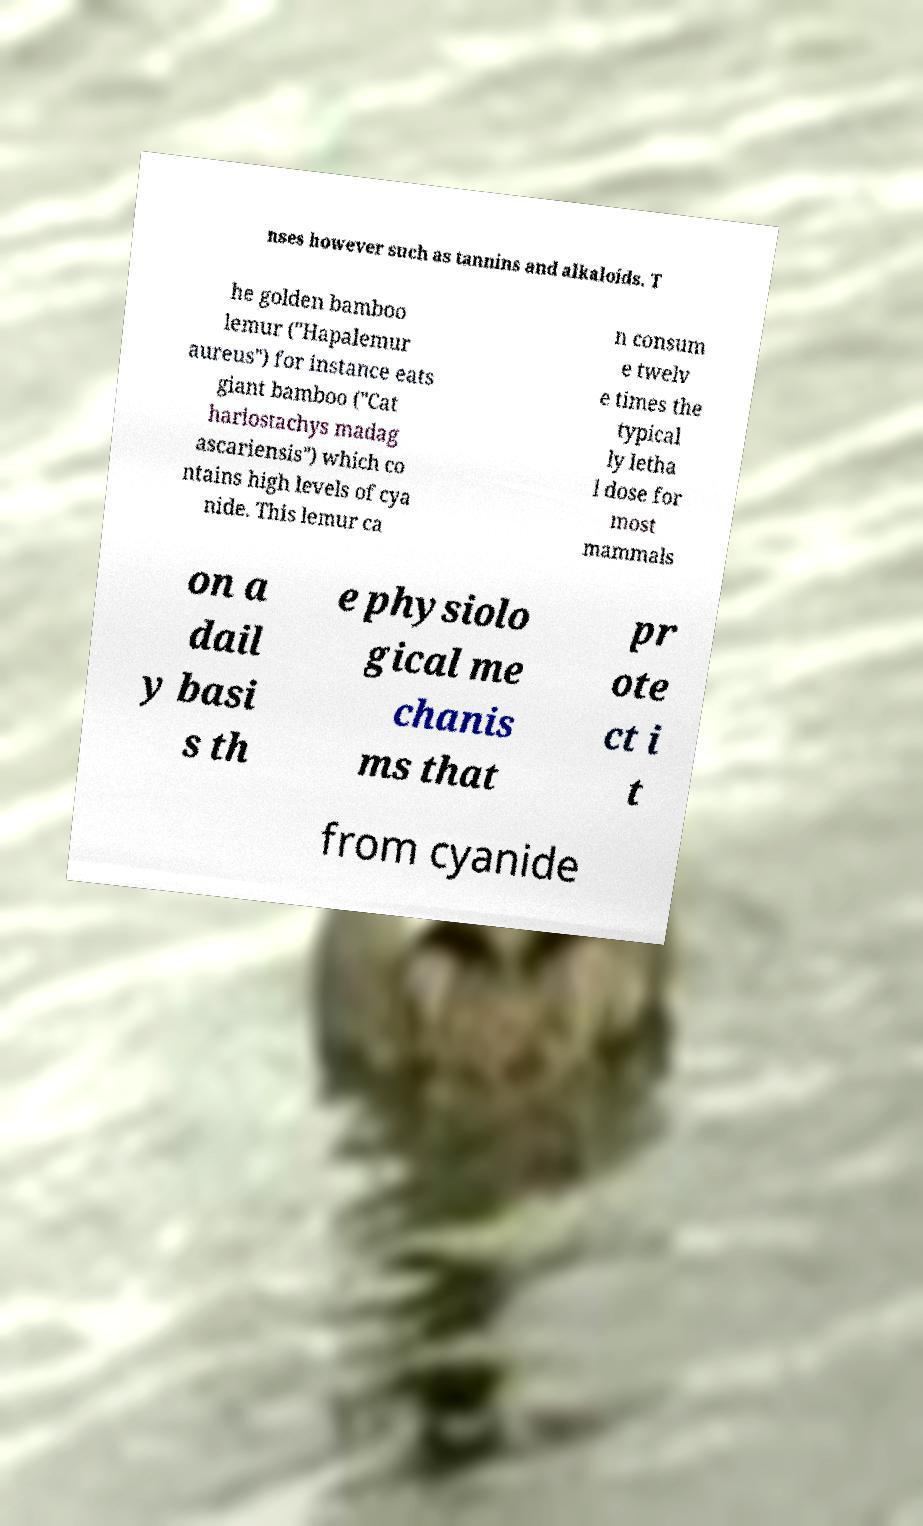For documentation purposes, I need the text within this image transcribed. Could you provide that? nses however such as tannins and alkaloids. T he golden bamboo lemur ("Hapalemur aureus") for instance eats giant bamboo ("Cat hariostachys madag ascariensis") which co ntains high levels of cya nide. This lemur ca n consum e twelv e times the typical ly letha l dose for most mammals on a dail y basi s th e physiolo gical me chanis ms that pr ote ct i t from cyanide 